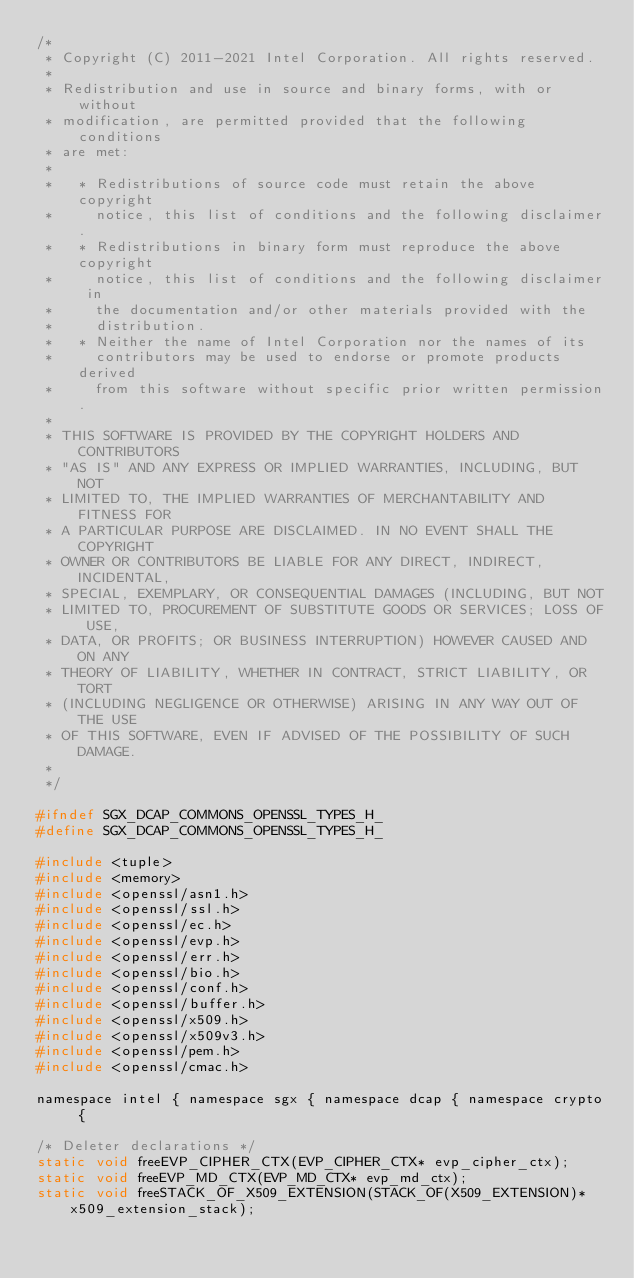<code> <loc_0><loc_0><loc_500><loc_500><_C_>/*
 * Copyright (C) 2011-2021 Intel Corporation. All rights reserved.
 *
 * Redistribution and use in source and binary forms, with or without
 * modification, are permitted provided that the following conditions
 * are met:
 *
 *   * Redistributions of source code must retain the above copyright
 *     notice, this list of conditions and the following disclaimer.
 *   * Redistributions in binary form must reproduce the above copyright
 *     notice, this list of conditions and the following disclaimer in
 *     the documentation and/or other materials provided with the
 *     distribution.
 *   * Neither the name of Intel Corporation nor the names of its
 *     contributors may be used to endorse or promote products derived
 *     from this software without specific prior written permission.
 *
 * THIS SOFTWARE IS PROVIDED BY THE COPYRIGHT HOLDERS AND CONTRIBUTORS
 * "AS IS" AND ANY EXPRESS OR IMPLIED WARRANTIES, INCLUDING, BUT NOT
 * LIMITED TO, THE IMPLIED WARRANTIES OF MERCHANTABILITY AND FITNESS FOR
 * A PARTICULAR PURPOSE ARE DISCLAIMED. IN NO EVENT SHALL THE COPYRIGHT
 * OWNER OR CONTRIBUTORS BE LIABLE FOR ANY DIRECT, INDIRECT, INCIDENTAL,
 * SPECIAL, EXEMPLARY, OR CONSEQUENTIAL DAMAGES (INCLUDING, BUT NOT
 * LIMITED TO, PROCUREMENT OF SUBSTITUTE GOODS OR SERVICES; LOSS OF USE,
 * DATA, OR PROFITS; OR BUSINESS INTERRUPTION) HOWEVER CAUSED AND ON ANY
 * THEORY OF LIABILITY, WHETHER IN CONTRACT, STRICT LIABILITY, OR TORT
 * (INCLUDING NEGLIGENCE OR OTHERWISE) ARISING IN ANY WAY OUT OF THE USE
 * OF THIS SOFTWARE, EVEN IF ADVISED OF THE POSSIBILITY OF SUCH DAMAGE.
 *
 */

#ifndef SGX_DCAP_COMMONS_OPENSSL_TYPES_H_
#define SGX_DCAP_COMMONS_OPENSSL_TYPES_H_

#include <tuple>
#include <memory>
#include <openssl/asn1.h>
#include <openssl/ssl.h>
#include <openssl/ec.h>
#include <openssl/evp.h>
#include <openssl/err.h>
#include <openssl/bio.h>
#include <openssl/conf.h>
#include <openssl/buffer.h>
#include <openssl/x509.h>
#include <openssl/x509v3.h>
#include <openssl/pem.h>
#include <openssl/cmac.h>

namespace intel { namespace sgx { namespace dcap { namespace crypto {

/* Deleter declarations */
static void freeEVP_CIPHER_CTX(EVP_CIPHER_CTX* evp_cipher_ctx);
static void freeEVP_MD_CTX(EVP_MD_CTX* evp_md_ctx);
static void freeSTACK_OF_X509_EXTENSION(STACK_OF(X509_EXTENSION)* x509_extension_stack);</code> 